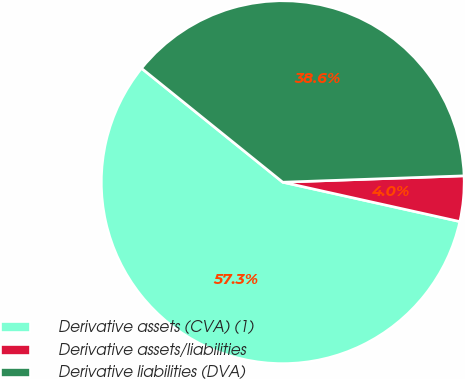<chart> <loc_0><loc_0><loc_500><loc_500><pie_chart><fcel>Derivative assets (CVA) (1)<fcel>Derivative assets/liabilities<fcel>Derivative liabilities (DVA)<nl><fcel>57.32%<fcel>4.04%<fcel>38.64%<nl></chart> 